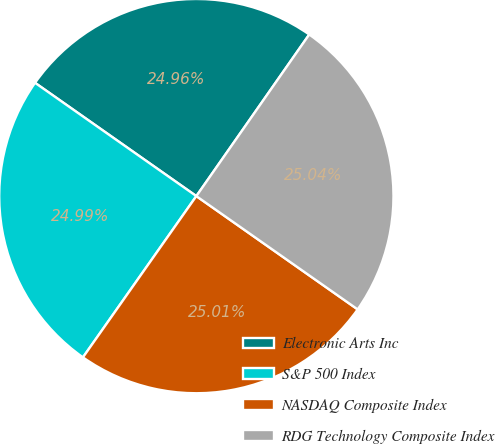Convert chart to OTSL. <chart><loc_0><loc_0><loc_500><loc_500><pie_chart><fcel>Electronic Arts Inc<fcel>S&P 500 Index<fcel>NASDAQ Composite Index<fcel>RDG Technology Composite Index<nl><fcel>24.96%<fcel>24.99%<fcel>25.01%<fcel>25.04%<nl></chart> 